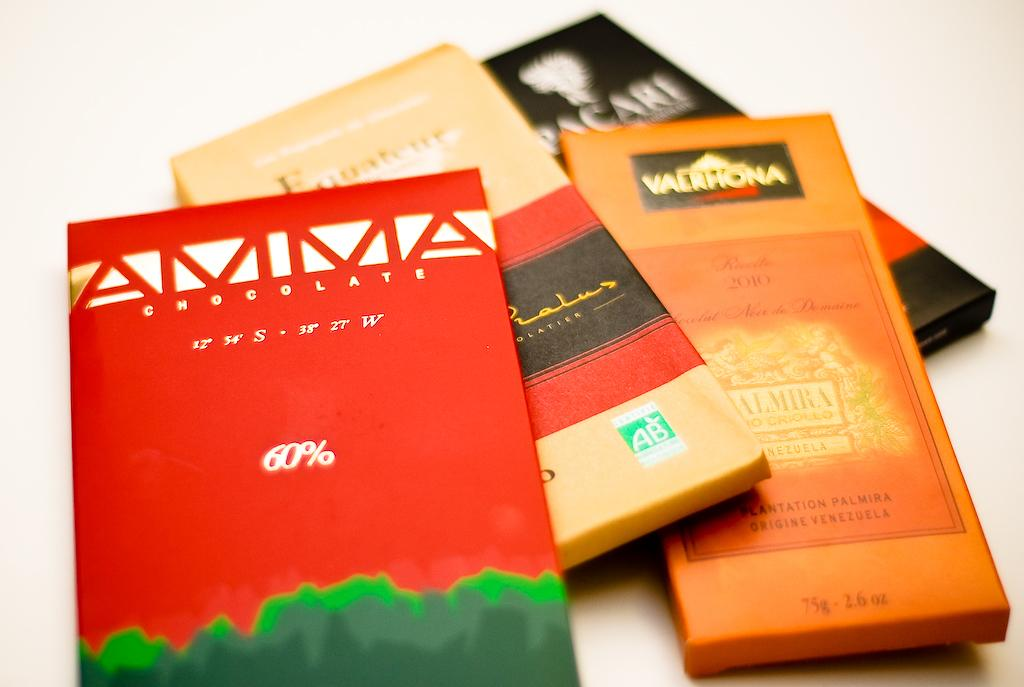<image>
Create a compact narrative representing the image presented. Coupons for Amma at 60% off in front of other ones. 